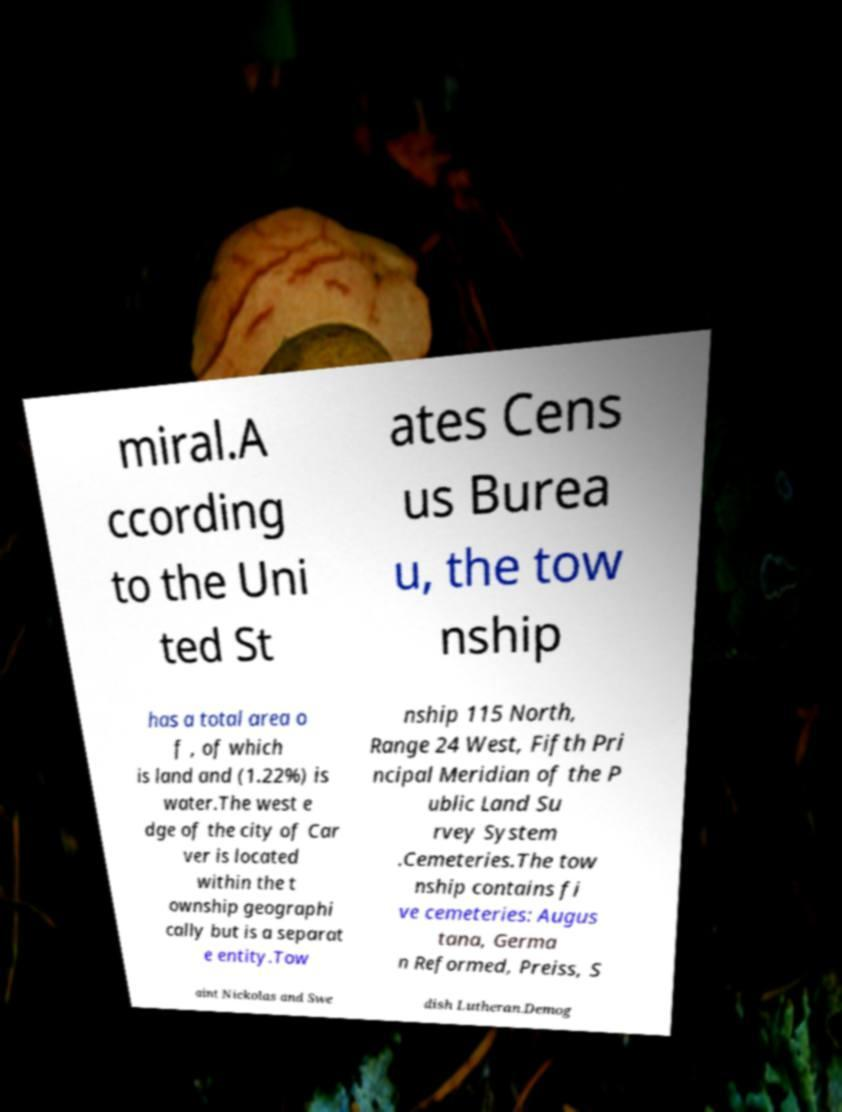There's text embedded in this image that I need extracted. Can you transcribe it verbatim? miral.A ccording to the Uni ted St ates Cens us Burea u, the tow nship has a total area o f , of which is land and (1.22%) is water.The west e dge of the city of Car ver is located within the t ownship geographi cally but is a separat e entity.Tow nship 115 North, Range 24 West, Fifth Pri ncipal Meridian of the P ublic Land Su rvey System .Cemeteries.The tow nship contains fi ve cemeteries: Augus tana, Germa n Reformed, Preiss, S aint Nickolas and Swe dish Lutheran.Demog 